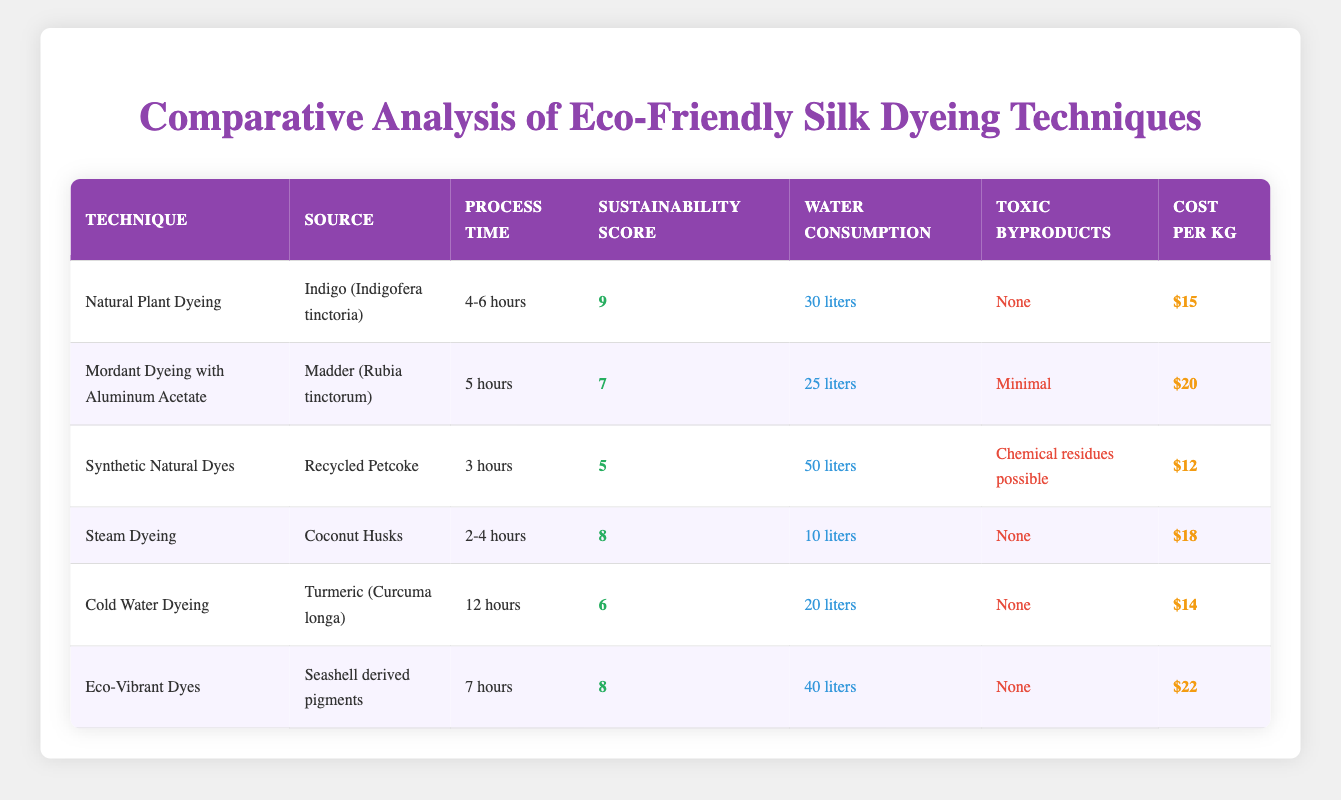What is the sustainability score for Natural Plant Dyeing? The sustainability score for Natural Plant Dyeing is displayed in the table, which shows a score of 9.
Answer: 9 Which dyeing technique has the highest water consumption? By looking at the water consumption column, Synthetic Natural Dyes has a water consumption of 50 liters, which is the highest among all techniques.
Answer: 50 liters Is there any technique that produces toxic byproducts? According to the table, only Synthetic Natural Dyes mentions toxic byproducts, stating "Chemical residues possible." The other techniques report "None" or "Minimal."
Answer: Yes What is the average cost per kg of all the dyeing techniques? To find the average cost, sum the costs: 15 + 20 + 12 + 18 + 14 + 22 = 111. Then divide by 6 (number of techniques): 111/6 ≈ 18.5.
Answer: 18.5 Which dyeing technique has the shortest dyeing process time? The dyeing process time for Synthetic Natural Dyes is the shortest at 3 hours, as indicated in the process time column.
Answer: 3 hours Does the Steam Dyeing technique have any toxic byproducts? The table states that Steam Dyeing has "None" regarding toxic byproducts, confirming it is free from toxins.
Answer: No What is the difference in sustainability score between Natural Plant Dyeing and Cold Water Dyeing? The sustainability score for Natural Plant Dyeing is 9, while for Cold Water Dyeing it is 6. Calculating the difference: 9 - 6 = 3.
Answer: 3 Which techniques have a sustainability score of 8 or above? Looking at the sustainability score column, the techniques that meet this criterion are Natural Plant Dyeing (9), Steam Dyeing (8), and Eco-Vibrant Dyes (8).
Answer: Natural Plant Dyeing, Steam Dyeing, Eco-Vibrant Dyes How many techniques have a dyeing process time of less than 5 hours? In the process time column, we count Synthetic Natural Dyes (3 hours), and Steam Dyeing (2-4 hours). So, there are 3 techniques with process times under 5 hours: Synthetic Natural Dyes, Steam Dyeing, and Mordant Dyeing with Aluminum Acetate (5 hours).
Answer: 3 